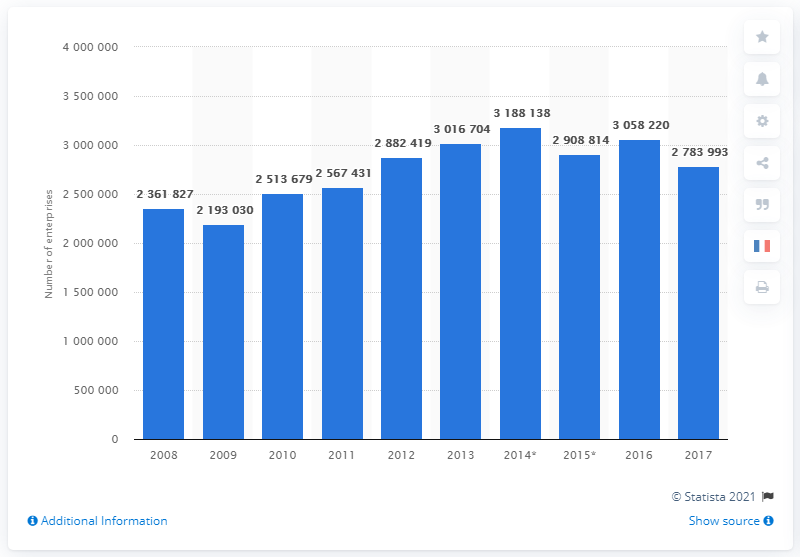Outline some significant characteristics in this image. In the year 2008, France began to engage in financial and insurance activities. In 2017, there were approximately 27,839,930 enterprises in France's business economy. 